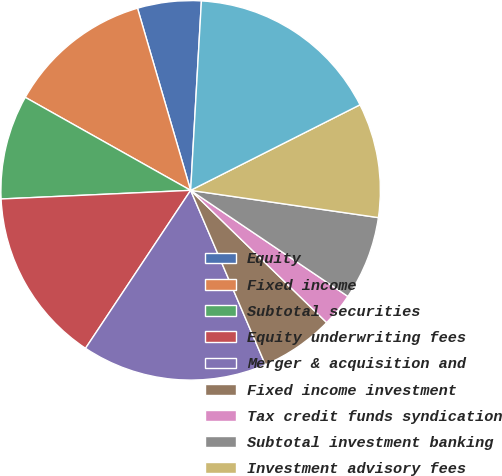Convert chart to OTSL. <chart><loc_0><loc_0><loc_500><loc_500><pie_chart><fcel>Equity<fcel>Fixed income<fcel>Subtotal securities<fcel>Equity underwriting fees<fcel>Merger & acquisition and<fcel>Fixed income investment<fcel>Tax credit funds syndication<fcel>Subtotal investment banking<fcel>Investment advisory fees<fcel>Net trading profit<nl><fcel>5.42%<fcel>12.33%<fcel>8.88%<fcel>14.93%<fcel>15.79%<fcel>6.28%<fcel>2.83%<fcel>7.15%<fcel>9.74%<fcel>16.65%<nl></chart> 